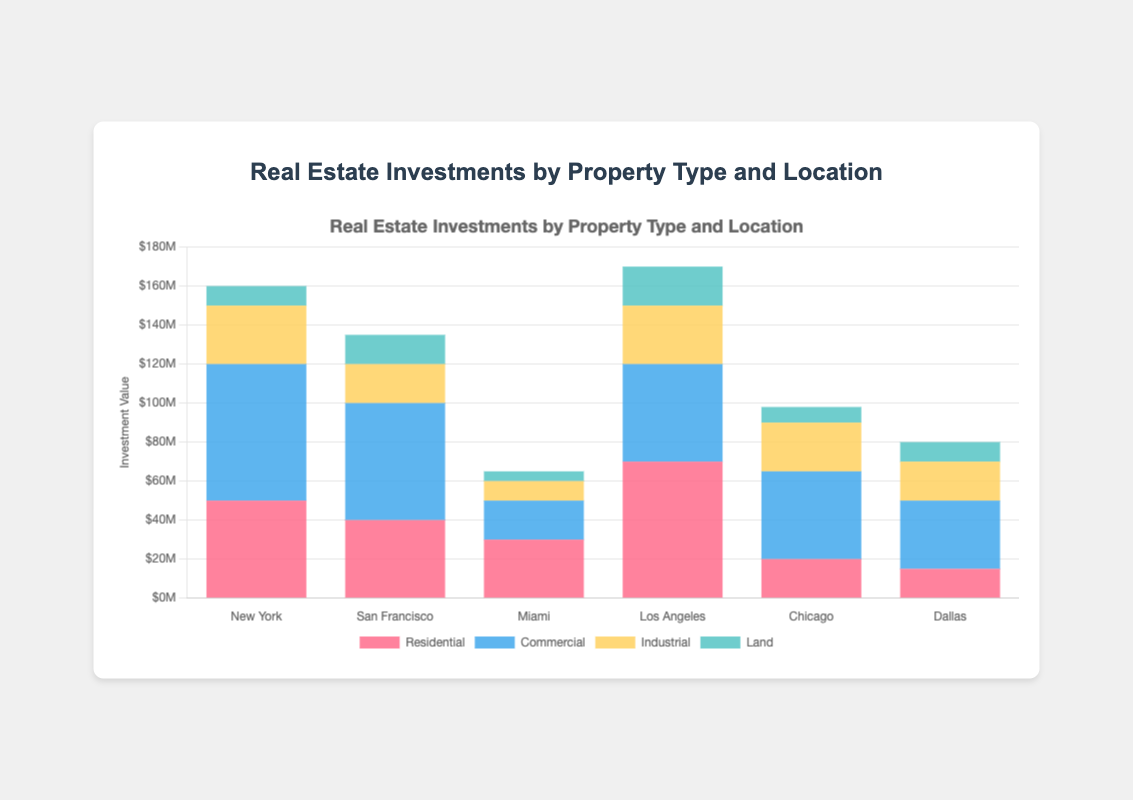What location has the highest total real estate investment? Sum the values of residential, commercial, industrial, and land for each location and compare the totals. New York: 160M, San Francisco: 135M, Miami: 65M, Los Angeles: 170M, Chicago: 98M, Dallas: 80M. Los Angeles has the highest total.
Answer: Los Angeles Which two locations have the largest difference in residential investments? Compare the residential investment values: New York: 50M, San Francisco: 40M, Miami: 30M, Los Angeles: 70M, Chicago: 20M, Dallas: 15M. The largest difference is between Los Angeles (70M) and Dallas (15M), which is 55M.
Answer: Los Angeles and Dallas Which property type has the largest total investment across all locations? Sum the investments per property type across all locations: Residential: 50M + 40M + 30M + 70M + 20M + 15M = 225M, Commercial: 70M + 60M + 20M + 50M + 45M + 35M = 280M, Industrial: 30M + 20M + 10M + 30M + 25M + 20M = 135M, Land: 10M + 15M + 5M + 20M + 8M + 10M = 68M. Commercial has the largest total investment (280M).
Answer: Commercial How much more does New York invest in commercial real estate compared to industrial real estate? Subtract the industrial investment in New York from the commercial investment: 70M - 30M = 40M.
Answer: 40M Which location has the smallest land investment? Compare the land investment values: New York: 10M, San Francisco: 15M, Miami: 5M, Los Angeles: 20M, Chicago: 8M, Dallas: 10M. Miami has the smallest land investment (5M).
Answer: Miami What is the average residential investment across all locations? Sum the residential investments and divide by the number of locations: (50M + 40M + 30M + 70M + 20M + 15M) / 6 = 225M / 6 = 37.5M.
Answer: 37.5M Which location has the highest industrial investment and what is the amount? Compare the industrial investment values: New York: 30M, San Francisco: 20M, Miami: 10M, Los Angeles: 30M, Chicago: 25M, Dallas: 20M. New York and Los Angeles both have the highest industrial investment (30M each).
Answer: New York and Los Angeles, 30M 